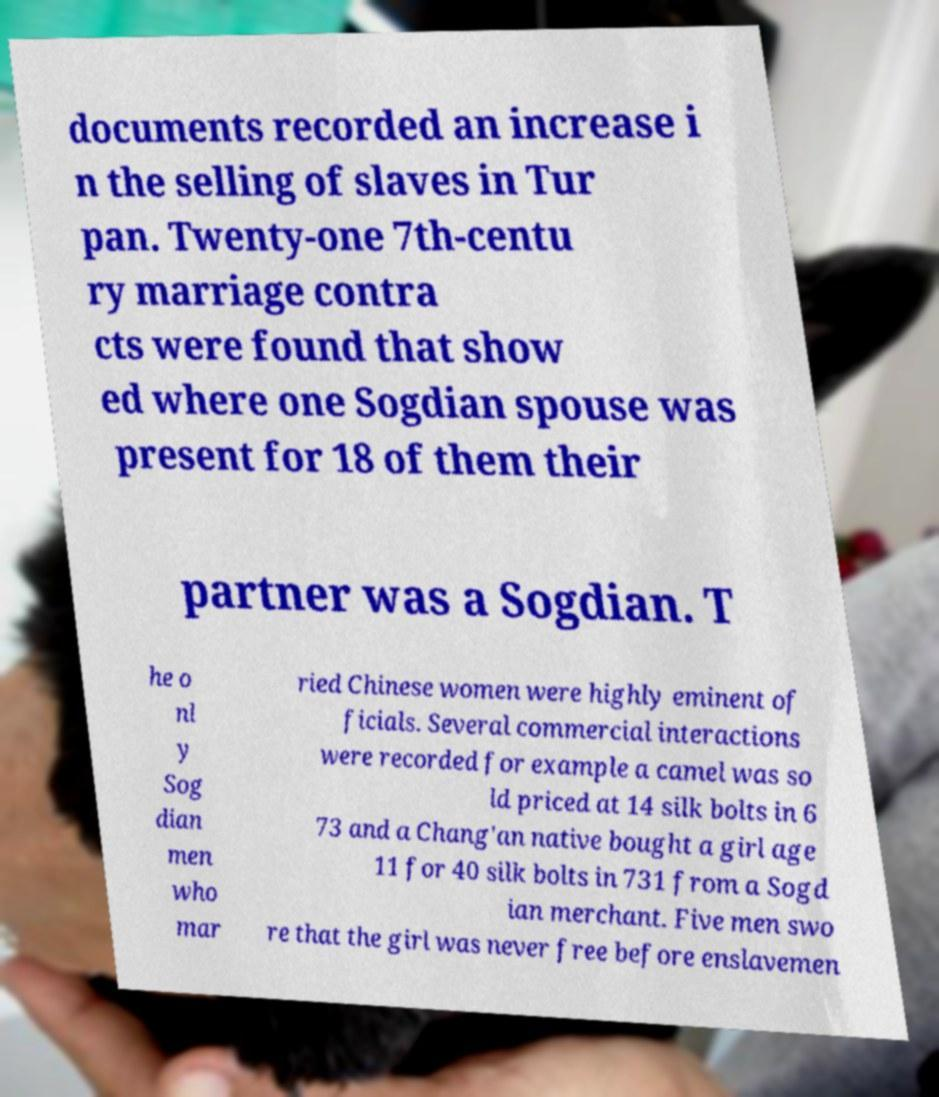Could you extract and type out the text from this image? documents recorded an increase i n the selling of slaves in Tur pan. Twenty-one 7th-centu ry marriage contra cts were found that show ed where one Sogdian spouse was present for 18 of them their partner was a Sogdian. T he o nl y Sog dian men who mar ried Chinese women were highly eminent of ficials. Several commercial interactions were recorded for example a camel was so ld priced at 14 silk bolts in 6 73 and a Chang'an native bought a girl age 11 for 40 silk bolts in 731 from a Sogd ian merchant. Five men swo re that the girl was never free before enslavemen 